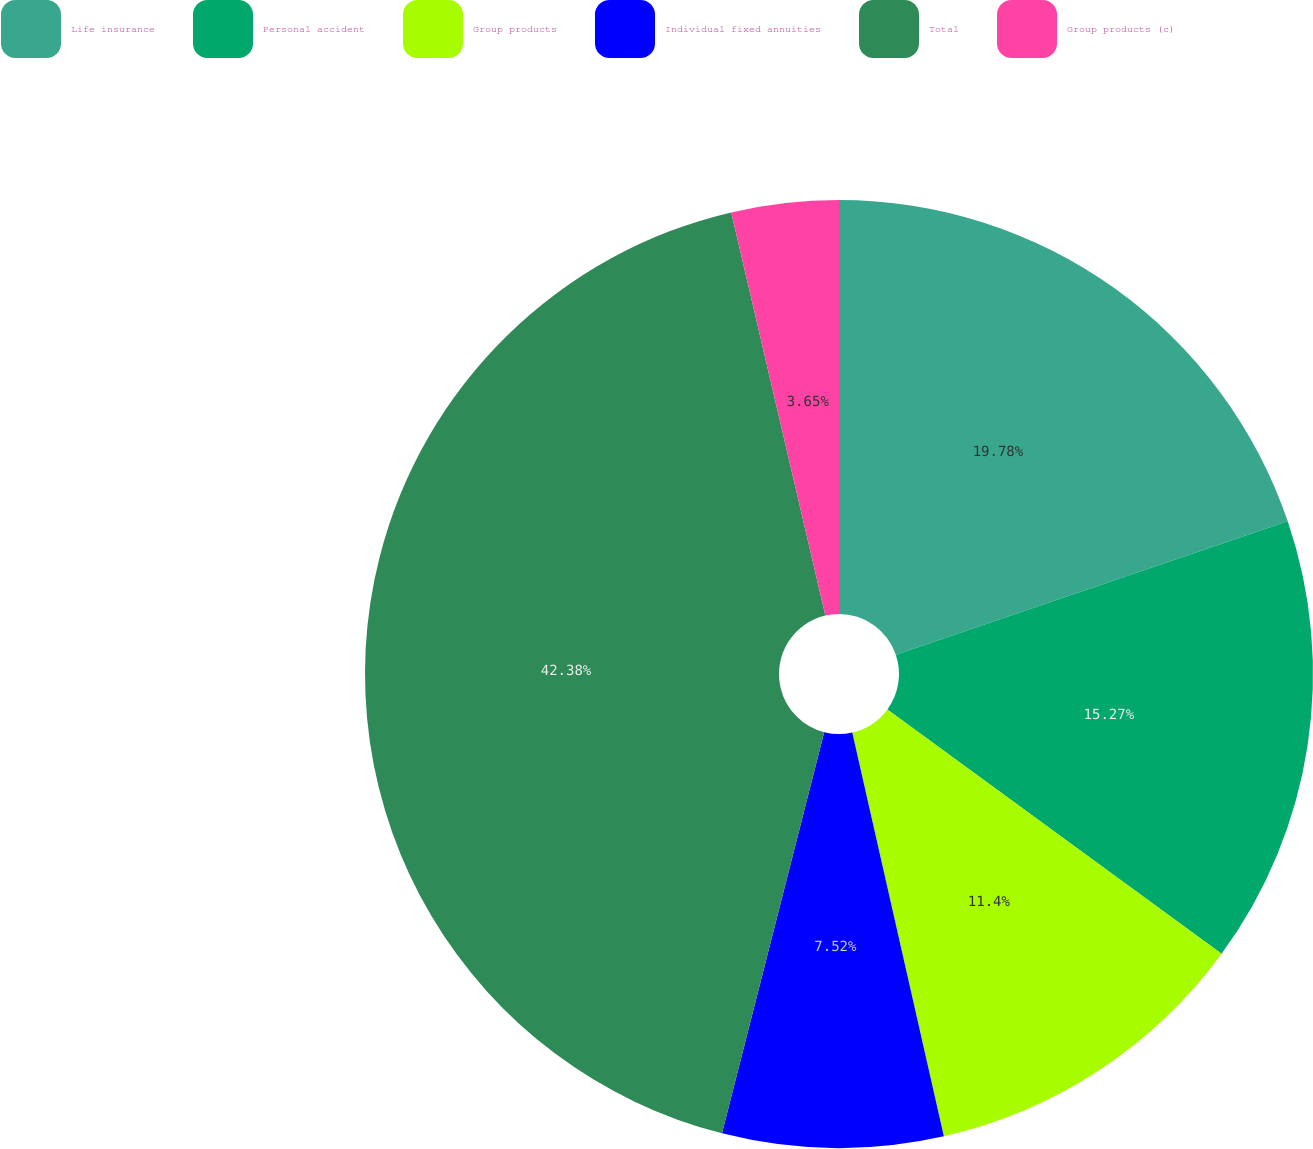Convert chart to OTSL. <chart><loc_0><loc_0><loc_500><loc_500><pie_chart><fcel>Life insurance<fcel>Personal accident<fcel>Group products<fcel>Individual fixed annuities<fcel>Total<fcel>Group products (c)<nl><fcel>19.78%<fcel>15.27%<fcel>11.4%<fcel>7.52%<fcel>42.38%<fcel>3.65%<nl></chart> 